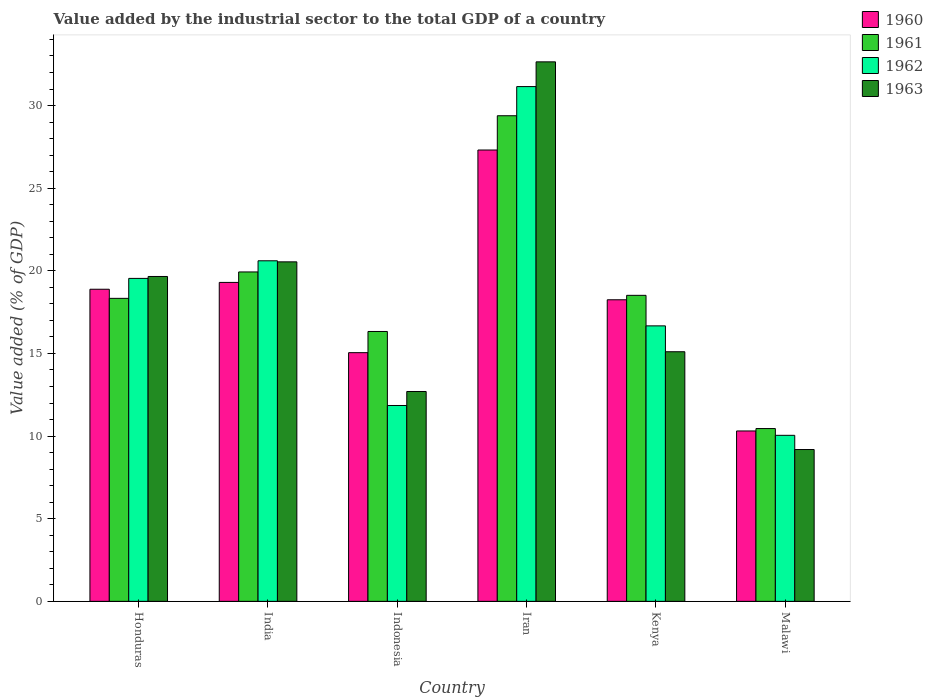How many different coloured bars are there?
Your answer should be very brief. 4. Are the number of bars per tick equal to the number of legend labels?
Make the answer very short. Yes. Are the number of bars on each tick of the X-axis equal?
Your answer should be very brief. Yes. How many bars are there on the 1st tick from the right?
Offer a terse response. 4. What is the label of the 4th group of bars from the left?
Ensure brevity in your answer.  Iran. What is the value added by the industrial sector to the total GDP in 1960 in India?
Make the answer very short. 19.3. Across all countries, what is the maximum value added by the industrial sector to the total GDP in 1962?
Provide a short and direct response. 31.15. Across all countries, what is the minimum value added by the industrial sector to the total GDP in 1962?
Offer a very short reply. 10.05. In which country was the value added by the industrial sector to the total GDP in 1960 maximum?
Your answer should be very brief. Iran. In which country was the value added by the industrial sector to the total GDP in 1960 minimum?
Offer a very short reply. Malawi. What is the total value added by the industrial sector to the total GDP in 1962 in the graph?
Give a very brief answer. 109.87. What is the difference between the value added by the industrial sector to the total GDP in 1961 in Indonesia and that in Iran?
Provide a short and direct response. -13.05. What is the difference between the value added by the industrial sector to the total GDP in 1961 in Malawi and the value added by the industrial sector to the total GDP in 1962 in India?
Your answer should be very brief. -10.15. What is the average value added by the industrial sector to the total GDP in 1961 per country?
Keep it short and to the point. 18.83. What is the difference between the value added by the industrial sector to the total GDP of/in 1963 and value added by the industrial sector to the total GDP of/in 1962 in Honduras?
Give a very brief answer. 0.12. What is the ratio of the value added by the industrial sector to the total GDP in 1960 in India to that in Malawi?
Provide a short and direct response. 1.87. Is the value added by the industrial sector to the total GDP in 1961 in India less than that in Indonesia?
Your answer should be compact. No. Is the difference between the value added by the industrial sector to the total GDP in 1963 in Indonesia and Malawi greater than the difference between the value added by the industrial sector to the total GDP in 1962 in Indonesia and Malawi?
Provide a short and direct response. Yes. What is the difference between the highest and the second highest value added by the industrial sector to the total GDP in 1961?
Give a very brief answer. -1.42. What is the difference between the highest and the lowest value added by the industrial sector to the total GDP in 1961?
Ensure brevity in your answer.  18.93. In how many countries, is the value added by the industrial sector to the total GDP in 1963 greater than the average value added by the industrial sector to the total GDP in 1963 taken over all countries?
Offer a very short reply. 3. Is it the case that in every country, the sum of the value added by the industrial sector to the total GDP in 1961 and value added by the industrial sector to the total GDP in 1960 is greater than the sum of value added by the industrial sector to the total GDP in 1963 and value added by the industrial sector to the total GDP in 1962?
Your response must be concise. No. What does the 2nd bar from the left in Malawi represents?
Ensure brevity in your answer.  1961. Is it the case that in every country, the sum of the value added by the industrial sector to the total GDP in 1961 and value added by the industrial sector to the total GDP in 1963 is greater than the value added by the industrial sector to the total GDP in 1962?
Provide a succinct answer. Yes. Are all the bars in the graph horizontal?
Your answer should be very brief. No. How many countries are there in the graph?
Give a very brief answer. 6. Does the graph contain any zero values?
Your answer should be very brief. No. Where does the legend appear in the graph?
Give a very brief answer. Top right. How are the legend labels stacked?
Ensure brevity in your answer.  Vertical. What is the title of the graph?
Make the answer very short. Value added by the industrial sector to the total GDP of a country. What is the label or title of the X-axis?
Your answer should be compact. Country. What is the label or title of the Y-axis?
Keep it short and to the point. Value added (% of GDP). What is the Value added (% of GDP) of 1960 in Honduras?
Provide a succinct answer. 18.89. What is the Value added (% of GDP) in 1961 in Honduras?
Your answer should be very brief. 18.33. What is the Value added (% of GDP) of 1962 in Honduras?
Your answer should be compact. 19.54. What is the Value added (% of GDP) of 1963 in Honduras?
Give a very brief answer. 19.66. What is the Value added (% of GDP) of 1960 in India?
Your answer should be compact. 19.3. What is the Value added (% of GDP) of 1961 in India?
Ensure brevity in your answer.  19.93. What is the Value added (% of GDP) of 1962 in India?
Give a very brief answer. 20.61. What is the Value added (% of GDP) in 1963 in India?
Provide a short and direct response. 20.54. What is the Value added (% of GDP) in 1960 in Indonesia?
Keep it short and to the point. 15.05. What is the Value added (% of GDP) of 1961 in Indonesia?
Offer a terse response. 16.33. What is the Value added (% of GDP) of 1962 in Indonesia?
Offer a very short reply. 11.85. What is the Value added (% of GDP) of 1963 in Indonesia?
Offer a very short reply. 12.7. What is the Value added (% of GDP) of 1960 in Iran?
Give a very brief answer. 27.31. What is the Value added (% of GDP) of 1961 in Iran?
Give a very brief answer. 29.38. What is the Value added (% of GDP) of 1962 in Iran?
Provide a succinct answer. 31.15. What is the Value added (% of GDP) of 1963 in Iran?
Your answer should be compact. 32.65. What is the Value added (% of GDP) of 1960 in Kenya?
Keep it short and to the point. 18.25. What is the Value added (% of GDP) of 1961 in Kenya?
Keep it short and to the point. 18.52. What is the Value added (% of GDP) of 1962 in Kenya?
Your response must be concise. 16.67. What is the Value added (% of GDP) of 1963 in Kenya?
Offer a very short reply. 15.1. What is the Value added (% of GDP) of 1960 in Malawi?
Offer a terse response. 10.31. What is the Value added (% of GDP) in 1961 in Malawi?
Ensure brevity in your answer.  10.46. What is the Value added (% of GDP) of 1962 in Malawi?
Make the answer very short. 10.05. What is the Value added (% of GDP) of 1963 in Malawi?
Your answer should be very brief. 9.19. Across all countries, what is the maximum Value added (% of GDP) in 1960?
Make the answer very short. 27.31. Across all countries, what is the maximum Value added (% of GDP) of 1961?
Offer a very short reply. 29.38. Across all countries, what is the maximum Value added (% of GDP) in 1962?
Give a very brief answer. 31.15. Across all countries, what is the maximum Value added (% of GDP) in 1963?
Keep it short and to the point. 32.65. Across all countries, what is the minimum Value added (% of GDP) in 1960?
Give a very brief answer. 10.31. Across all countries, what is the minimum Value added (% of GDP) of 1961?
Provide a succinct answer. 10.46. Across all countries, what is the minimum Value added (% of GDP) in 1962?
Keep it short and to the point. 10.05. Across all countries, what is the minimum Value added (% of GDP) in 1963?
Your answer should be very brief. 9.19. What is the total Value added (% of GDP) in 1960 in the graph?
Offer a terse response. 109.11. What is the total Value added (% of GDP) of 1961 in the graph?
Provide a short and direct response. 112.96. What is the total Value added (% of GDP) of 1962 in the graph?
Your response must be concise. 109.87. What is the total Value added (% of GDP) of 1963 in the graph?
Offer a terse response. 109.84. What is the difference between the Value added (% of GDP) in 1960 in Honduras and that in India?
Offer a very short reply. -0.41. What is the difference between the Value added (% of GDP) in 1961 in Honduras and that in India?
Offer a terse response. -1.6. What is the difference between the Value added (% of GDP) of 1962 in Honduras and that in India?
Provide a short and direct response. -1.07. What is the difference between the Value added (% of GDP) in 1963 in Honduras and that in India?
Give a very brief answer. -0.88. What is the difference between the Value added (% of GDP) in 1960 in Honduras and that in Indonesia?
Your answer should be compact. 3.84. What is the difference between the Value added (% of GDP) in 1961 in Honduras and that in Indonesia?
Your response must be concise. 2. What is the difference between the Value added (% of GDP) of 1962 in Honduras and that in Indonesia?
Offer a terse response. 7.69. What is the difference between the Value added (% of GDP) in 1963 in Honduras and that in Indonesia?
Offer a very short reply. 6.96. What is the difference between the Value added (% of GDP) of 1960 in Honduras and that in Iran?
Your response must be concise. -8.43. What is the difference between the Value added (% of GDP) in 1961 in Honduras and that in Iran?
Your answer should be compact. -11.05. What is the difference between the Value added (% of GDP) of 1962 in Honduras and that in Iran?
Provide a succinct answer. -11.61. What is the difference between the Value added (% of GDP) of 1963 in Honduras and that in Iran?
Your answer should be very brief. -12.99. What is the difference between the Value added (% of GDP) in 1960 in Honduras and that in Kenya?
Make the answer very short. 0.64. What is the difference between the Value added (% of GDP) in 1961 in Honduras and that in Kenya?
Your response must be concise. -0.18. What is the difference between the Value added (% of GDP) of 1962 in Honduras and that in Kenya?
Give a very brief answer. 2.87. What is the difference between the Value added (% of GDP) in 1963 in Honduras and that in Kenya?
Give a very brief answer. 4.55. What is the difference between the Value added (% of GDP) in 1960 in Honduras and that in Malawi?
Your response must be concise. 8.57. What is the difference between the Value added (% of GDP) in 1961 in Honduras and that in Malawi?
Offer a terse response. 7.88. What is the difference between the Value added (% of GDP) in 1962 in Honduras and that in Malawi?
Ensure brevity in your answer.  9.49. What is the difference between the Value added (% of GDP) in 1963 in Honduras and that in Malawi?
Offer a terse response. 10.47. What is the difference between the Value added (% of GDP) in 1960 in India and that in Indonesia?
Provide a short and direct response. 4.25. What is the difference between the Value added (% of GDP) of 1961 in India and that in Indonesia?
Offer a terse response. 3.6. What is the difference between the Value added (% of GDP) in 1962 in India and that in Indonesia?
Make the answer very short. 8.76. What is the difference between the Value added (% of GDP) in 1963 in India and that in Indonesia?
Keep it short and to the point. 7.84. What is the difference between the Value added (% of GDP) in 1960 in India and that in Iran?
Provide a succinct answer. -8.01. What is the difference between the Value added (% of GDP) of 1961 in India and that in Iran?
Your answer should be compact. -9.45. What is the difference between the Value added (% of GDP) in 1962 in India and that in Iran?
Your answer should be very brief. -10.54. What is the difference between the Value added (% of GDP) of 1963 in India and that in Iran?
Offer a terse response. -12.1. What is the difference between the Value added (% of GDP) in 1960 in India and that in Kenya?
Your answer should be very brief. 1.05. What is the difference between the Value added (% of GDP) in 1961 in India and that in Kenya?
Ensure brevity in your answer.  1.42. What is the difference between the Value added (% of GDP) in 1962 in India and that in Kenya?
Keep it short and to the point. 3.94. What is the difference between the Value added (% of GDP) of 1963 in India and that in Kenya?
Provide a short and direct response. 5.44. What is the difference between the Value added (% of GDP) in 1960 in India and that in Malawi?
Make the answer very short. 8.99. What is the difference between the Value added (% of GDP) in 1961 in India and that in Malawi?
Provide a short and direct response. 9.48. What is the difference between the Value added (% of GDP) in 1962 in India and that in Malawi?
Provide a short and direct response. 10.56. What is the difference between the Value added (% of GDP) of 1963 in India and that in Malawi?
Your answer should be very brief. 11.36. What is the difference between the Value added (% of GDP) in 1960 in Indonesia and that in Iran?
Keep it short and to the point. -12.26. What is the difference between the Value added (% of GDP) in 1961 in Indonesia and that in Iran?
Offer a very short reply. -13.05. What is the difference between the Value added (% of GDP) in 1962 in Indonesia and that in Iran?
Keep it short and to the point. -19.3. What is the difference between the Value added (% of GDP) of 1963 in Indonesia and that in Iran?
Ensure brevity in your answer.  -19.95. What is the difference between the Value added (% of GDP) of 1960 in Indonesia and that in Kenya?
Your answer should be compact. -3.2. What is the difference between the Value added (% of GDP) in 1961 in Indonesia and that in Kenya?
Your response must be concise. -2.19. What is the difference between the Value added (% of GDP) in 1962 in Indonesia and that in Kenya?
Your answer should be compact. -4.82. What is the difference between the Value added (% of GDP) of 1963 in Indonesia and that in Kenya?
Make the answer very short. -2.4. What is the difference between the Value added (% of GDP) of 1960 in Indonesia and that in Malawi?
Ensure brevity in your answer.  4.74. What is the difference between the Value added (% of GDP) in 1961 in Indonesia and that in Malawi?
Keep it short and to the point. 5.87. What is the difference between the Value added (% of GDP) of 1962 in Indonesia and that in Malawi?
Ensure brevity in your answer.  1.8. What is the difference between the Value added (% of GDP) in 1963 in Indonesia and that in Malawi?
Provide a short and direct response. 3.51. What is the difference between the Value added (% of GDP) in 1960 in Iran and that in Kenya?
Ensure brevity in your answer.  9.06. What is the difference between the Value added (% of GDP) in 1961 in Iran and that in Kenya?
Ensure brevity in your answer.  10.87. What is the difference between the Value added (% of GDP) in 1962 in Iran and that in Kenya?
Your response must be concise. 14.48. What is the difference between the Value added (% of GDP) of 1963 in Iran and that in Kenya?
Your answer should be compact. 17.54. What is the difference between the Value added (% of GDP) of 1960 in Iran and that in Malawi?
Ensure brevity in your answer.  17. What is the difference between the Value added (% of GDP) in 1961 in Iran and that in Malawi?
Provide a short and direct response. 18.93. What is the difference between the Value added (% of GDP) of 1962 in Iran and that in Malawi?
Your answer should be very brief. 21.1. What is the difference between the Value added (% of GDP) in 1963 in Iran and that in Malawi?
Ensure brevity in your answer.  23.46. What is the difference between the Value added (% of GDP) in 1960 in Kenya and that in Malawi?
Ensure brevity in your answer.  7.94. What is the difference between the Value added (% of GDP) of 1961 in Kenya and that in Malawi?
Your answer should be compact. 8.06. What is the difference between the Value added (% of GDP) in 1962 in Kenya and that in Malawi?
Ensure brevity in your answer.  6.62. What is the difference between the Value added (% of GDP) of 1963 in Kenya and that in Malawi?
Offer a terse response. 5.92. What is the difference between the Value added (% of GDP) of 1960 in Honduras and the Value added (% of GDP) of 1961 in India?
Make the answer very short. -1.05. What is the difference between the Value added (% of GDP) of 1960 in Honduras and the Value added (% of GDP) of 1962 in India?
Your response must be concise. -1.72. What is the difference between the Value added (% of GDP) in 1960 in Honduras and the Value added (% of GDP) in 1963 in India?
Your answer should be very brief. -1.66. What is the difference between the Value added (% of GDP) of 1961 in Honduras and the Value added (% of GDP) of 1962 in India?
Offer a terse response. -2.27. What is the difference between the Value added (% of GDP) of 1961 in Honduras and the Value added (% of GDP) of 1963 in India?
Offer a very short reply. -2.21. What is the difference between the Value added (% of GDP) in 1962 in Honduras and the Value added (% of GDP) in 1963 in India?
Ensure brevity in your answer.  -1. What is the difference between the Value added (% of GDP) of 1960 in Honduras and the Value added (% of GDP) of 1961 in Indonesia?
Make the answer very short. 2.56. What is the difference between the Value added (% of GDP) of 1960 in Honduras and the Value added (% of GDP) of 1962 in Indonesia?
Your answer should be compact. 7.03. What is the difference between the Value added (% of GDP) in 1960 in Honduras and the Value added (% of GDP) in 1963 in Indonesia?
Make the answer very short. 6.19. What is the difference between the Value added (% of GDP) of 1961 in Honduras and the Value added (% of GDP) of 1962 in Indonesia?
Make the answer very short. 6.48. What is the difference between the Value added (% of GDP) in 1961 in Honduras and the Value added (% of GDP) in 1963 in Indonesia?
Provide a succinct answer. 5.64. What is the difference between the Value added (% of GDP) in 1962 in Honduras and the Value added (% of GDP) in 1963 in Indonesia?
Keep it short and to the point. 6.84. What is the difference between the Value added (% of GDP) of 1960 in Honduras and the Value added (% of GDP) of 1961 in Iran?
Offer a terse response. -10.5. What is the difference between the Value added (% of GDP) in 1960 in Honduras and the Value added (% of GDP) in 1962 in Iran?
Your answer should be compact. -12.26. What is the difference between the Value added (% of GDP) of 1960 in Honduras and the Value added (% of GDP) of 1963 in Iran?
Provide a short and direct response. -13.76. What is the difference between the Value added (% of GDP) in 1961 in Honduras and the Value added (% of GDP) in 1962 in Iran?
Offer a terse response. -12.81. What is the difference between the Value added (% of GDP) in 1961 in Honduras and the Value added (% of GDP) in 1963 in Iran?
Give a very brief answer. -14.31. What is the difference between the Value added (% of GDP) in 1962 in Honduras and the Value added (% of GDP) in 1963 in Iran?
Offer a terse response. -13.1. What is the difference between the Value added (% of GDP) in 1960 in Honduras and the Value added (% of GDP) in 1961 in Kenya?
Make the answer very short. 0.37. What is the difference between the Value added (% of GDP) of 1960 in Honduras and the Value added (% of GDP) of 1962 in Kenya?
Ensure brevity in your answer.  2.22. What is the difference between the Value added (% of GDP) in 1960 in Honduras and the Value added (% of GDP) in 1963 in Kenya?
Your answer should be compact. 3.78. What is the difference between the Value added (% of GDP) of 1961 in Honduras and the Value added (% of GDP) of 1962 in Kenya?
Your answer should be very brief. 1.66. What is the difference between the Value added (% of GDP) in 1961 in Honduras and the Value added (% of GDP) in 1963 in Kenya?
Give a very brief answer. 3.23. What is the difference between the Value added (% of GDP) in 1962 in Honduras and the Value added (% of GDP) in 1963 in Kenya?
Offer a terse response. 4.44. What is the difference between the Value added (% of GDP) of 1960 in Honduras and the Value added (% of GDP) of 1961 in Malawi?
Keep it short and to the point. 8.43. What is the difference between the Value added (% of GDP) of 1960 in Honduras and the Value added (% of GDP) of 1962 in Malawi?
Your answer should be compact. 8.84. What is the difference between the Value added (% of GDP) in 1960 in Honduras and the Value added (% of GDP) in 1963 in Malawi?
Your answer should be compact. 9.7. What is the difference between the Value added (% of GDP) of 1961 in Honduras and the Value added (% of GDP) of 1962 in Malawi?
Offer a very short reply. 8.29. What is the difference between the Value added (% of GDP) in 1961 in Honduras and the Value added (% of GDP) in 1963 in Malawi?
Keep it short and to the point. 9.15. What is the difference between the Value added (% of GDP) of 1962 in Honduras and the Value added (% of GDP) of 1963 in Malawi?
Your response must be concise. 10.36. What is the difference between the Value added (% of GDP) of 1960 in India and the Value added (% of GDP) of 1961 in Indonesia?
Offer a terse response. 2.97. What is the difference between the Value added (% of GDP) of 1960 in India and the Value added (% of GDP) of 1962 in Indonesia?
Ensure brevity in your answer.  7.45. What is the difference between the Value added (% of GDP) of 1960 in India and the Value added (% of GDP) of 1963 in Indonesia?
Offer a terse response. 6.6. What is the difference between the Value added (% of GDP) in 1961 in India and the Value added (% of GDP) in 1962 in Indonesia?
Your answer should be very brief. 8.08. What is the difference between the Value added (% of GDP) of 1961 in India and the Value added (% of GDP) of 1963 in Indonesia?
Make the answer very short. 7.23. What is the difference between the Value added (% of GDP) of 1962 in India and the Value added (% of GDP) of 1963 in Indonesia?
Your answer should be compact. 7.91. What is the difference between the Value added (% of GDP) in 1960 in India and the Value added (% of GDP) in 1961 in Iran?
Your answer should be very brief. -10.09. What is the difference between the Value added (% of GDP) of 1960 in India and the Value added (% of GDP) of 1962 in Iran?
Give a very brief answer. -11.85. What is the difference between the Value added (% of GDP) of 1960 in India and the Value added (% of GDP) of 1963 in Iran?
Keep it short and to the point. -13.35. What is the difference between the Value added (% of GDP) of 1961 in India and the Value added (% of GDP) of 1962 in Iran?
Your answer should be compact. -11.22. What is the difference between the Value added (% of GDP) in 1961 in India and the Value added (% of GDP) in 1963 in Iran?
Make the answer very short. -12.71. What is the difference between the Value added (% of GDP) of 1962 in India and the Value added (% of GDP) of 1963 in Iran?
Give a very brief answer. -12.04. What is the difference between the Value added (% of GDP) of 1960 in India and the Value added (% of GDP) of 1961 in Kenya?
Make the answer very short. 0.78. What is the difference between the Value added (% of GDP) in 1960 in India and the Value added (% of GDP) in 1962 in Kenya?
Your answer should be very brief. 2.63. What is the difference between the Value added (% of GDP) of 1960 in India and the Value added (% of GDP) of 1963 in Kenya?
Provide a short and direct response. 4.2. What is the difference between the Value added (% of GDP) of 1961 in India and the Value added (% of GDP) of 1962 in Kenya?
Offer a terse response. 3.26. What is the difference between the Value added (% of GDP) in 1961 in India and the Value added (% of GDP) in 1963 in Kenya?
Give a very brief answer. 4.83. What is the difference between the Value added (% of GDP) in 1962 in India and the Value added (% of GDP) in 1963 in Kenya?
Ensure brevity in your answer.  5.5. What is the difference between the Value added (% of GDP) in 1960 in India and the Value added (% of GDP) in 1961 in Malawi?
Provide a succinct answer. 8.84. What is the difference between the Value added (% of GDP) of 1960 in India and the Value added (% of GDP) of 1962 in Malawi?
Offer a very short reply. 9.25. What is the difference between the Value added (% of GDP) in 1960 in India and the Value added (% of GDP) in 1963 in Malawi?
Your answer should be compact. 10.11. What is the difference between the Value added (% of GDP) of 1961 in India and the Value added (% of GDP) of 1962 in Malawi?
Your answer should be very brief. 9.89. What is the difference between the Value added (% of GDP) of 1961 in India and the Value added (% of GDP) of 1963 in Malawi?
Your answer should be compact. 10.75. What is the difference between the Value added (% of GDP) in 1962 in India and the Value added (% of GDP) in 1963 in Malawi?
Keep it short and to the point. 11.42. What is the difference between the Value added (% of GDP) in 1960 in Indonesia and the Value added (% of GDP) in 1961 in Iran?
Your response must be concise. -14.34. What is the difference between the Value added (% of GDP) in 1960 in Indonesia and the Value added (% of GDP) in 1962 in Iran?
Ensure brevity in your answer.  -16.1. What is the difference between the Value added (% of GDP) of 1960 in Indonesia and the Value added (% of GDP) of 1963 in Iran?
Your answer should be compact. -17.6. What is the difference between the Value added (% of GDP) in 1961 in Indonesia and the Value added (% of GDP) in 1962 in Iran?
Make the answer very short. -14.82. What is the difference between the Value added (% of GDP) in 1961 in Indonesia and the Value added (% of GDP) in 1963 in Iran?
Provide a short and direct response. -16.32. What is the difference between the Value added (% of GDP) of 1962 in Indonesia and the Value added (% of GDP) of 1963 in Iran?
Your response must be concise. -20.79. What is the difference between the Value added (% of GDP) of 1960 in Indonesia and the Value added (% of GDP) of 1961 in Kenya?
Your answer should be compact. -3.47. What is the difference between the Value added (% of GDP) of 1960 in Indonesia and the Value added (% of GDP) of 1962 in Kenya?
Offer a terse response. -1.62. What is the difference between the Value added (% of GDP) of 1960 in Indonesia and the Value added (% of GDP) of 1963 in Kenya?
Make the answer very short. -0.06. What is the difference between the Value added (% of GDP) of 1961 in Indonesia and the Value added (% of GDP) of 1962 in Kenya?
Make the answer very short. -0.34. What is the difference between the Value added (% of GDP) of 1961 in Indonesia and the Value added (% of GDP) of 1963 in Kenya?
Provide a short and direct response. 1.23. What is the difference between the Value added (% of GDP) in 1962 in Indonesia and the Value added (% of GDP) in 1963 in Kenya?
Your response must be concise. -3.25. What is the difference between the Value added (% of GDP) in 1960 in Indonesia and the Value added (% of GDP) in 1961 in Malawi?
Make the answer very short. 4.59. What is the difference between the Value added (% of GDP) in 1960 in Indonesia and the Value added (% of GDP) in 1962 in Malawi?
Provide a short and direct response. 5. What is the difference between the Value added (% of GDP) of 1960 in Indonesia and the Value added (% of GDP) of 1963 in Malawi?
Provide a succinct answer. 5.86. What is the difference between the Value added (% of GDP) in 1961 in Indonesia and the Value added (% of GDP) in 1962 in Malawi?
Provide a succinct answer. 6.28. What is the difference between the Value added (% of GDP) in 1961 in Indonesia and the Value added (% of GDP) in 1963 in Malawi?
Your response must be concise. 7.14. What is the difference between the Value added (% of GDP) of 1962 in Indonesia and the Value added (% of GDP) of 1963 in Malawi?
Offer a terse response. 2.66. What is the difference between the Value added (% of GDP) of 1960 in Iran and the Value added (% of GDP) of 1961 in Kenya?
Provide a succinct answer. 8.79. What is the difference between the Value added (% of GDP) in 1960 in Iran and the Value added (% of GDP) in 1962 in Kenya?
Give a very brief answer. 10.64. What is the difference between the Value added (% of GDP) of 1960 in Iran and the Value added (% of GDP) of 1963 in Kenya?
Your answer should be compact. 12.21. What is the difference between the Value added (% of GDP) of 1961 in Iran and the Value added (% of GDP) of 1962 in Kenya?
Keep it short and to the point. 12.71. What is the difference between the Value added (% of GDP) of 1961 in Iran and the Value added (% of GDP) of 1963 in Kenya?
Offer a very short reply. 14.28. What is the difference between the Value added (% of GDP) in 1962 in Iran and the Value added (% of GDP) in 1963 in Kenya?
Keep it short and to the point. 16.04. What is the difference between the Value added (% of GDP) in 1960 in Iran and the Value added (% of GDP) in 1961 in Malawi?
Provide a short and direct response. 16.86. What is the difference between the Value added (% of GDP) in 1960 in Iran and the Value added (% of GDP) in 1962 in Malawi?
Provide a succinct answer. 17.26. What is the difference between the Value added (% of GDP) of 1960 in Iran and the Value added (% of GDP) of 1963 in Malawi?
Your response must be concise. 18.12. What is the difference between the Value added (% of GDP) in 1961 in Iran and the Value added (% of GDP) in 1962 in Malawi?
Provide a short and direct response. 19.34. What is the difference between the Value added (% of GDP) in 1961 in Iran and the Value added (% of GDP) in 1963 in Malawi?
Give a very brief answer. 20.2. What is the difference between the Value added (% of GDP) of 1962 in Iran and the Value added (% of GDP) of 1963 in Malawi?
Ensure brevity in your answer.  21.96. What is the difference between the Value added (% of GDP) in 1960 in Kenya and the Value added (% of GDP) in 1961 in Malawi?
Your answer should be very brief. 7.79. What is the difference between the Value added (% of GDP) of 1960 in Kenya and the Value added (% of GDP) of 1962 in Malawi?
Your answer should be very brief. 8.2. What is the difference between the Value added (% of GDP) of 1960 in Kenya and the Value added (% of GDP) of 1963 in Malawi?
Offer a very short reply. 9.06. What is the difference between the Value added (% of GDP) in 1961 in Kenya and the Value added (% of GDP) in 1962 in Malawi?
Give a very brief answer. 8.47. What is the difference between the Value added (% of GDP) in 1961 in Kenya and the Value added (% of GDP) in 1963 in Malawi?
Your answer should be compact. 9.33. What is the difference between the Value added (% of GDP) of 1962 in Kenya and the Value added (% of GDP) of 1963 in Malawi?
Provide a succinct answer. 7.48. What is the average Value added (% of GDP) of 1960 per country?
Your answer should be compact. 18.18. What is the average Value added (% of GDP) in 1961 per country?
Ensure brevity in your answer.  18.83. What is the average Value added (% of GDP) in 1962 per country?
Ensure brevity in your answer.  18.31. What is the average Value added (% of GDP) of 1963 per country?
Offer a very short reply. 18.31. What is the difference between the Value added (% of GDP) of 1960 and Value added (% of GDP) of 1961 in Honduras?
Give a very brief answer. 0.55. What is the difference between the Value added (% of GDP) in 1960 and Value added (% of GDP) in 1962 in Honduras?
Your answer should be very brief. -0.66. What is the difference between the Value added (% of GDP) of 1960 and Value added (% of GDP) of 1963 in Honduras?
Give a very brief answer. -0.77. What is the difference between the Value added (% of GDP) in 1961 and Value added (% of GDP) in 1962 in Honduras?
Your answer should be compact. -1.21. What is the difference between the Value added (% of GDP) of 1961 and Value added (% of GDP) of 1963 in Honduras?
Your response must be concise. -1.32. What is the difference between the Value added (% of GDP) in 1962 and Value added (% of GDP) in 1963 in Honduras?
Offer a very short reply. -0.12. What is the difference between the Value added (% of GDP) in 1960 and Value added (% of GDP) in 1961 in India?
Ensure brevity in your answer.  -0.63. What is the difference between the Value added (% of GDP) in 1960 and Value added (% of GDP) in 1962 in India?
Keep it short and to the point. -1.31. What is the difference between the Value added (% of GDP) of 1960 and Value added (% of GDP) of 1963 in India?
Ensure brevity in your answer.  -1.24. What is the difference between the Value added (% of GDP) of 1961 and Value added (% of GDP) of 1962 in India?
Ensure brevity in your answer.  -0.68. What is the difference between the Value added (% of GDP) of 1961 and Value added (% of GDP) of 1963 in India?
Offer a terse response. -0.61. What is the difference between the Value added (% of GDP) of 1962 and Value added (% of GDP) of 1963 in India?
Your answer should be compact. 0.06. What is the difference between the Value added (% of GDP) in 1960 and Value added (% of GDP) in 1961 in Indonesia?
Keep it short and to the point. -1.28. What is the difference between the Value added (% of GDP) in 1960 and Value added (% of GDP) in 1962 in Indonesia?
Give a very brief answer. 3.2. What is the difference between the Value added (% of GDP) in 1960 and Value added (% of GDP) in 1963 in Indonesia?
Provide a short and direct response. 2.35. What is the difference between the Value added (% of GDP) in 1961 and Value added (% of GDP) in 1962 in Indonesia?
Provide a succinct answer. 4.48. What is the difference between the Value added (% of GDP) in 1961 and Value added (% of GDP) in 1963 in Indonesia?
Your response must be concise. 3.63. What is the difference between the Value added (% of GDP) in 1962 and Value added (% of GDP) in 1963 in Indonesia?
Make the answer very short. -0.85. What is the difference between the Value added (% of GDP) of 1960 and Value added (% of GDP) of 1961 in Iran?
Your answer should be compact. -2.07. What is the difference between the Value added (% of GDP) of 1960 and Value added (% of GDP) of 1962 in Iran?
Provide a short and direct response. -3.84. What is the difference between the Value added (% of GDP) of 1960 and Value added (% of GDP) of 1963 in Iran?
Your answer should be very brief. -5.33. What is the difference between the Value added (% of GDP) of 1961 and Value added (% of GDP) of 1962 in Iran?
Provide a succinct answer. -1.76. What is the difference between the Value added (% of GDP) of 1961 and Value added (% of GDP) of 1963 in Iran?
Ensure brevity in your answer.  -3.26. What is the difference between the Value added (% of GDP) in 1962 and Value added (% of GDP) in 1963 in Iran?
Ensure brevity in your answer.  -1.5. What is the difference between the Value added (% of GDP) in 1960 and Value added (% of GDP) in 1961 in Kenya?
Keep it short and to the point. -0.27. What is the difference between the Value added (% of GDP) of 1960 and Value added (% of GDP) of 1962 in Kenya?
Ensure brevity in your answer.  1.58. What is the difference between the Value added (% of GDP) of 1960 and Value added (% of GDP) of 1963 in Kenya?
Provide a succinct answer. 3.14. What is the difference between the Value added (% of GDP) in 1961 and Value added (% of GDP) in 1962 in Kenya?
Ensure brevity in your answer.  1.85. What is the difference between the Value added (% of GDP) of 1961 and Value added (% of GDP) of 1963 in Kenya?
Provide a short and direct response. 3.41. What is the difference between the Value added (% of GDP) in 1962 and Value added (% of GDP) in 1963 in Kenya?
Give a very brief answer. 1.57. What is the difference between the Value added (% of GDP) of 1960 and Value added (% of GDP) of 1961 in Malawi?
Give a very brief answer. -0.15. What is the difference between the Value added (% of GDP) of 1960 and Value added (% of GDP) of 1962 in Malawi?
Offer a very short reply. 0.26. What is the difference between the Value added (% of GDP) in 1960 and Value added (% of GDP) in 1963 in Malawi?
Keep it short and to the point. 1.12. What is the difference between the Value added (% of GDP) in 1961 and Value added (% of GDP) in 1962 in Malawi?
Offer a very short reply. 0.41. What is the difference between the Value added (% of GDP) in 1961 and Value added (% of GDP) in 1963 in Malawi?
Provide a short and direct response. 1.27. What is the difference between the Value added (% of GDP) in 1962 and Value added (% of GDP) in 1963 in Malawi?
Your response must be concise. 0.86. What is the ratio of the Value added (% of GDP) in 1960 in Honduras to that in India?
Your answer should be very brief. 0.98. What is the ratio of the Value added (% of GDP) of 1961 in Honduras to that in India?
Keep it short and to the point. 0.92. What is the ratio of the Value added (% of GDP) of 1962 in Honduras to that in India?
Keep it short and to the point. 0.95. What is the ratio of the Value added (% of GDP) of 1963 in Honduras to that in India?
Your answer should be very brief. 0.96. What is the ratio of the Value added (% of GDP) of 1960 in Honduras to that in Indonesia?
Your answer should be compact. 1.25. What is the ratio of the Value added (% of GDP) of 1961 in Honduras to that in Indonesia?
Offer a terse response. 1.12. What is the ratio of the Value added (% of GDP) in 1962 in Honduras to that in Indonesia?
Your response must be concise. 1.65. What is the ratio of the Value added (% of GDP) in 1963 in Honduras to that in Indonesia?
Offer a very short reply. 1.55. What is the ratio of the Value added (% of GDP) in 1960 in Honduras to that in Iran?
Provide a succinct answer. 0.69. What is the ratio of the Value added (% of GDP) in 1961 in Honduras to that in Iran?
Your response must be concise. 0.62. What is the ratio of the Value added (% of GDP) in 1962 in Honduras to that in Iran?
Your response must be concise. 0.63. What is the ratio of the Value added (% of GDP) of 1963 in Honduras to that in Iran?
Provide a short and direct response. 0.6. What is the ratio of the Value added (% of GDP) of 1960 in Honduras to that in Kenya?
Offer a terse response. 1.03. What is the ratio of the Value added (% of GDP) of 1962 in Honduras to that in Kenya?
Provide a succinct answer. 1.17. What is the ratio of the Value added (% of GDP) in 1963 in Honduras to that in Kenya?
Provide a succinct answer. 1.3. What is the ratio of the Value added (% of GDP) of 1960 in Honduras to that in Malawi?
Your answer should be compact. 1.83. What is the ratio of the Value added (% of GDP) in 1961 in Honduras to that in Malawi?
Your answer should be compact. 1.75. What is the ratio of the Value added (% of GDP) in 1962 in Honduras to that in Malawi?
Your answer should be very brief. 1.95. What is the ratio of the Value added (% of GDP) in 1963 in Honduras to that in Malawi?
Keep it short and to the point. 2.14. What is the ratio of the Value added (% of GDP) in 1960 in India to that in Indonesia?
Provide a short and direct response. 1.28. What is the ratio of the Value added (% of GDP) in 1961 in India to that in Indonesia?
Your response must be concise. 1.22. What is the ratio of the Value added (% of GDP) in 1962 in India to that in Indonesia?
Offer a very short reply. 1.74. What is the ratio of the Value added (% of GDP) in 1963 in India to that in Indonesia?
Provide a succinct answer. 1.62. What is the ratio of the Value added (% of GDP) of 1960 in India to that in Iran?
Your response must be concise. 0.71. What is the ratio of the Value added (% of GDP) in 1961 in India to that in Iran?
Keep it short and to the point. 0.68. What is the ratio of the Value added (% of GDP) in 1962 in India to that in Iran?
Provide a short and direct response. 0.66. What is the ratio of the Value added (% of GDP) in 1963 in India to that in Iran?
Provide a succinct answer. 0.63. What is the ratio of the Value added (% of GDP) of 1960 in India to that in Kenya?
Offer a terse response. 1.06. What is the ratio of the Value added (% of GDP) in 1961 in India to that in Kenya?
Give a very brief answer. 1.08. What is the ratio of the Value added (% of GDP) of 1962 in India to that in Kenya?
Offer a terse response. 1.24. What is the ratio of the Value added (% of GDP) in 1963 in India to that in Kenya?
Offer a terse response. 1.36. What is the ratio of the Value added (% of GDP) of 1960 in India to that in Malawi?
Make the answer very short. 1.87. What is the ratio of the Value added (% of GDP) in 1961 in India to that in Malawi?
Your answer should be very brief. 1.91. What is the ratio of the Value added (% of GDP) in 1962 in India to that in Malawi?
Your answer should be very brief. 2.05. What is the ratio of the Value added (% of GDP) of 1963 in India to that in Malawi?
Offer a very short reply. 2.24. What is the ratio of the Value added (% of GDP) in 1960 in Indonesia to that in Iran?
Provide a short and direct response. 0.55. What is the ratio of the Value added (% of GDP) of 1961 in Indonesia to that in Iran?
Ensure brevity in your answer.  0.56. What is the ratio of the Value added (% of GDP) of 1962 in Indonesia to that in Iran?
Give a very brief answer. 0.38. What is the ratio of the Value added (% of GDP) of 1963 in Indonesia to that in Iran?
Give a very brief answer. 0.39. What is the ratio of the Value added (% of GDP) of 1960 in Indonesia to that in Kenya?
Your response must be concise. 0.82. What is the ratio of the Value added (% of GDP) of 1961 in Indonesia to that in Kenya?
Give a very brief answer. 0.88. What is the ratio of the Value added (% of GDP) of 1962 in Indonesia to that in Kenya?
Make the answer very short. 0.71. What is the ratio of the Value added (% of GDP) in 1963 in Indonesia to that in Kenya?
Your answer should be compact. 0.84. What is the ratio of the Value added (% of GDP) in 1960 in Indonesia to that in Malawi?
Your answer should be compact. 1.46. What is the ratio of the Value added (% of GDP) in 1961 in Indonesia to that in Malawi?
Your answer should be very brief. 1.56. What is the ratio of the Value added (% of GDP) in 1962 in Indonesia to that in Malawi?
Your answer should be compact. 1.18. What is the ratio of the Value added (% of GDP) in 1963 in Indonesia to that in Malawi?
Your answer should be compact. 1.38. What is the ratio of the Value added (% of GDP) of 1960 in Iran to that in Kenya?
Provide a succinct answer. 1.5. What is the ratio of the Value added (% of GDP) of 1961 in Iran to that in Kenya?
Keep it short and to the point. 1.59. What is the ratio of the Value added (% of GDP) in 1962 in Iran to that in Kenya?
Your response must be concise. 1.87. What is the ratio of the Value added (% of GDP) of 1963 in Iran to that in Kenya?
Your answer should be compact. 2.16. What is the ratio of the Value added (% of GDP) of 1960 in Iran to that in Malawi?
Offer a very short reply. 2.65. What is the ratio of the Value added (% of GDP) of 1961 in Iran to that in Malawi?
Your response must be concise. 2.81. What is the ratio of the Value added (% of GDP) of 1962 in Iran to that in Malawi?
Provide a succinct answer. 3.1. What is the ratio of the Value added (% of GDP) of 1963 in Iran to that in Malawi?
Offer a very short reply. 3.55. What is the ratio of the Value added (% of GDP) in 1960 in Kenya to that in Malawi?
Offer a terse response. 1.77. What is the ratio of the Value added (% of GDP) in 1961 in Kenya to that in Malawi?
Your answer should be compact. 1.77. What is the ratio of the Value added (% of GDP) in 1962 in Kenya to that in Malawi?
Ensure brevity in your answer.  1.66. What is the ratio of the Value added (% of GDP) in 1963 in Kenya to that in Malawi?
Your answer should be compact. 1.64. What is the difference between the highest and the second highest Value added (% of GDP) of 1960?
Your answer should be compact. 8.01. What is the difference between the highest and the second highest Value added (% of GDP) in 1961?
Keep it short and to the point. 9.45. What is the difference between the highest and the second highest Value added (% of GDP) in 1962?
Your response must be concise. 10.54. What is the difference between the highest and the second highest Value added (% of GDP) of 1963?
Give a very brief answer. 12.1. What is the difference between the highest and the lowest Value added (% of GDP) in 1960?
Your answer should be compact. 17. What is the difference between the highest and the lowest Value added (% of GDP) in 1961?
Provide a short and direct response. 18.93. What is the difference between the highest and the lowest Value added (% of GDP) in 1962?
Your response must be concise. 21.1. What is the difference between the highest and the lowest Value added (% of GDP) in 1963?
Ensure brevity in your answer.  23.46. 